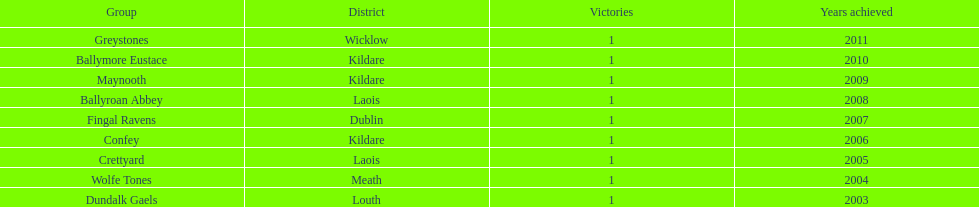Parse the full table. {'header': ['Group', 'District', 'Victories', 'Years achieved'], 'rows': [['Greystones', 'Wicklow', '1', '2011'], ['Ballymore Eustace', 'Kildare', '1', '2010'], ['Maynooth', 'Kildare', '1', '2009'], ['Ballyroan Abbey', 'Laois', '1', '2008'], ['Fingal Ravens', 'Dublin', '1', '2007'], ['Confey', 'Kildare', '1', '2006'], ['Crettyard', 'Laois', '1', '2005'], ['Wolfe Tones', 'Meath', '1', '2004'], ['Dundalk Gaels', 'Louth', '1', '2003']]} What team comes before confey Fingal Ravens. 